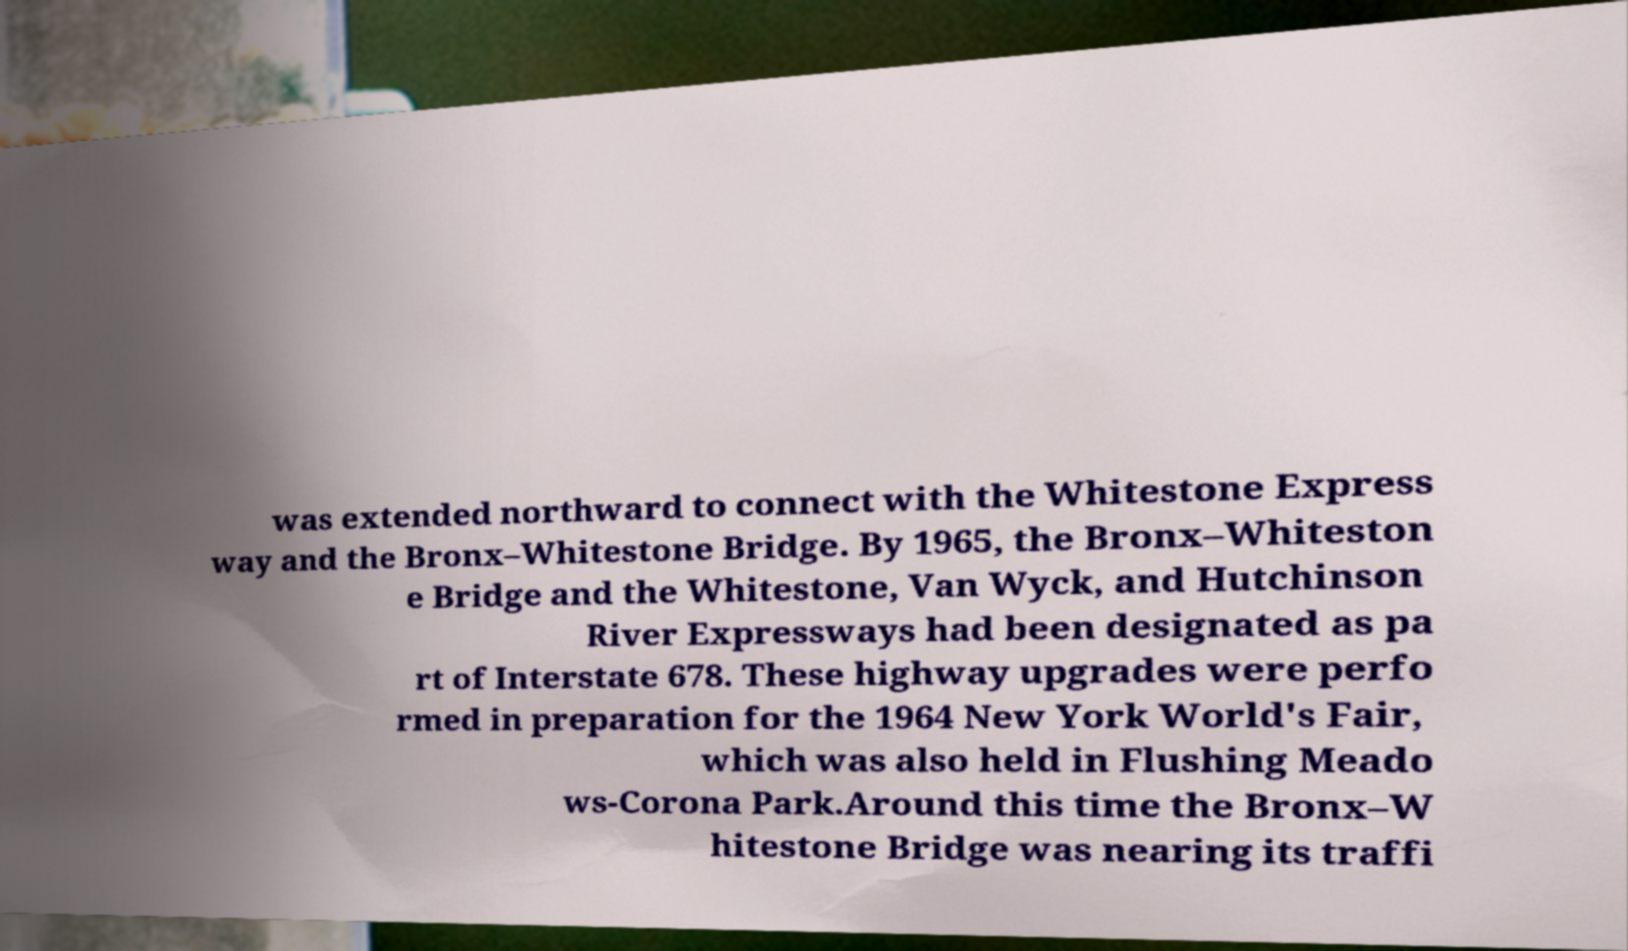Please identify and transcribe the text found in this image. was extended northward to connect with the Whitestone Express way and the Bronx–Whitestone Bridge. By 1965, the Bronx–Whiteston e Bridge and the Whitestone, Van Wyck, and Hutchinson River Expressways had been designated as pa rt of Interstate 678. These highway upgrades were perfo rmed in preparation for the 1964 New York World's Fair, which was also held in Flushing Meado ws-Corona Park.Around this time the Bronx–W hitestone Bridge was nearing its traffi 